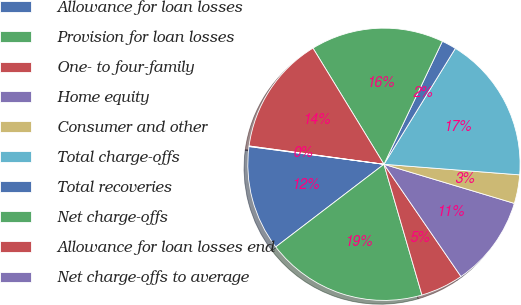<chart> <loc_0><loc_0><loc_500><loc_500><pie_chart><fcel>Allowance for loan losses<fcel>Provision for loan losses<fcel>One- to four-family<fcel>Home equity<fcel>Consumer and other<fcel>Total charge-offs<fcel>Total recoveries<fcel>Net charge-offs<fcel>Allowance for loan losses end<fcel>Net charge-offs to average<nl><fcel>12.46%<fcel>19.12%<fcel>5.07%<fcel>10.79%<fcel>3.4%<fcel>17.45%<fcel>1.73%<fcel>15.79%<fcel>14.12%<fcel>0.07%<nl></chart> 